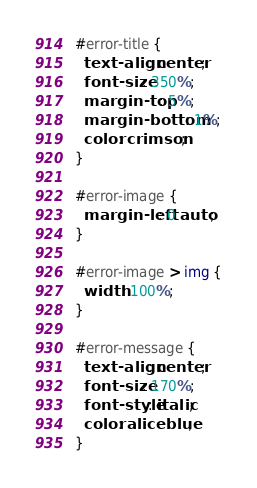Convert code to text. <code><loc_0><loc_0><loc_500><loc_500><_CSS_>#error-title {
  text-align: center;
  font-size: 350%;
  margin-top: 5%;
  margin-bottom: 1%;
  color: crimson;
}

#error-image {
  margin-left: 0 auto;
}

#error-image > img {
  width: 100%;
}

#error-message {
  text-align: center;
  font-size: 170%;
  font-style: italic;
  color: aliceblue;
}</code> 